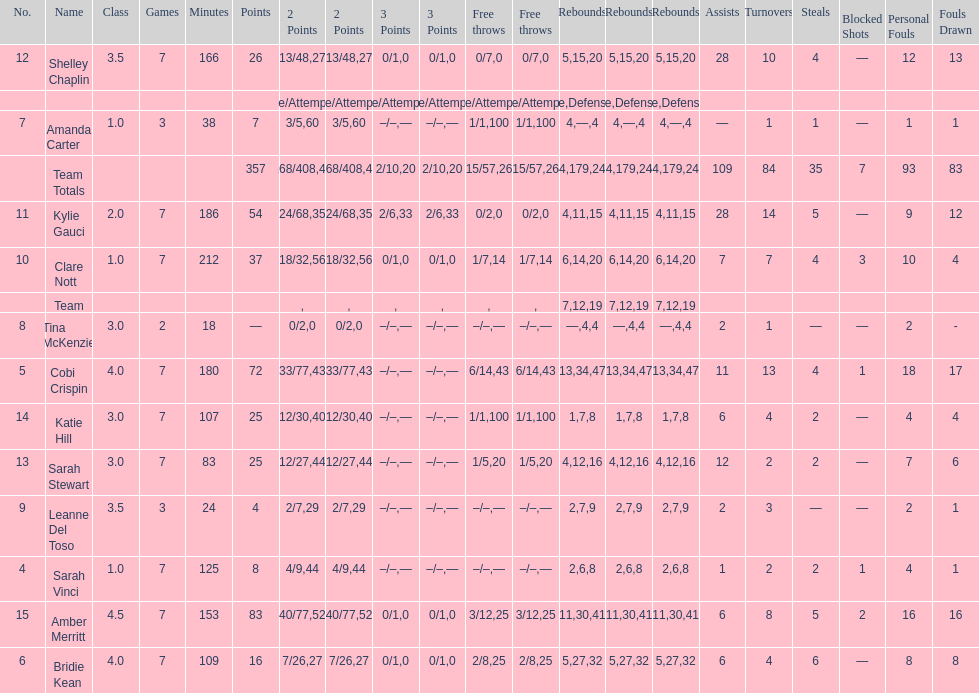Adjacent to merritt, who had the most points? Cobi Crispin. 